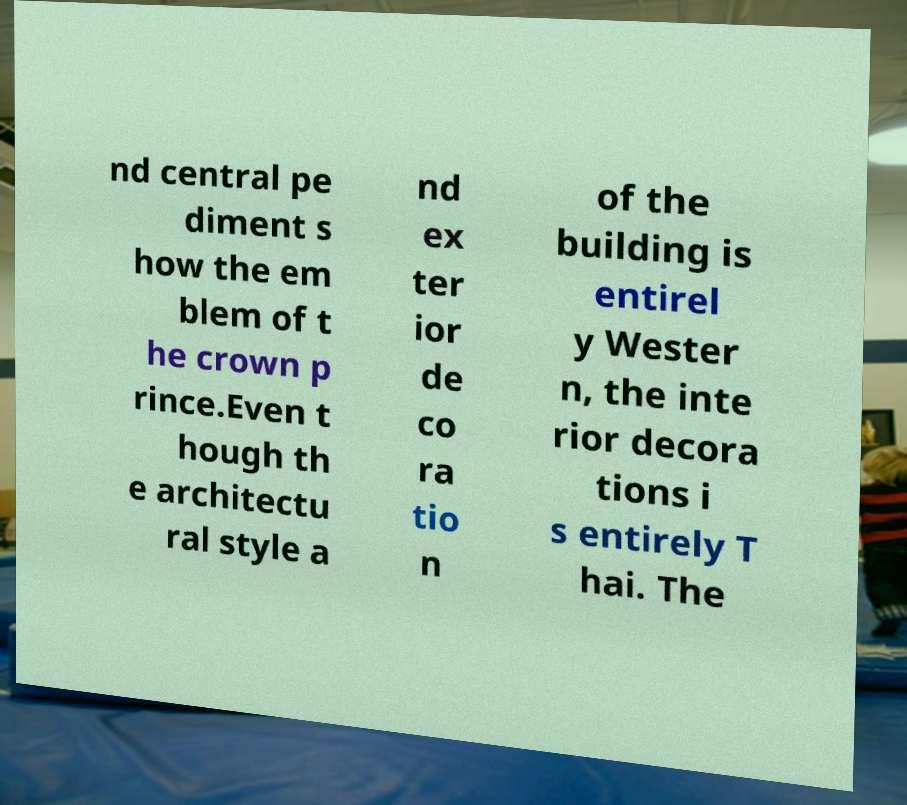Please read and relay the text visible in this image. What does it say? nd central pe diment s how the em blem of t he crown p rince.Even t hough th e architectu ral style a nd ex ter ior de co ra tio n of the building is entirel y Wester n, the inte rior decora tions i s entirely T hai. The 